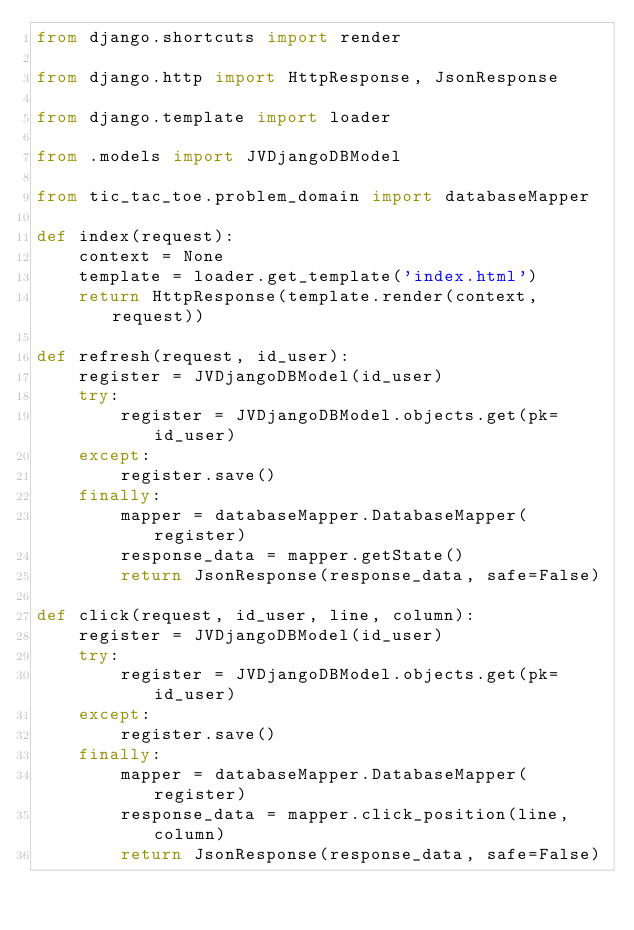Convert code to text. <code><loc_0><loc_0><loc_500><loc_500><_Python_>from django.shortcuts import render

from django.http import HttpResponse, JsonResponse

from django.template import loader

from .models import JVDjangoDBModel

from tic_tac_toe.problem_domain import databaseMapper

def index(request):
    context = None
    template = loader.get_template('index.html')
    return HttpResponse(template.render(context, request))

def refresh(request, id_user):
    register = JVDjangoDBModel(id_user)
    try:
        register = JVDjangoDBModel.objects.get(pk=id_user)
    except:
        register.save()
    finally:
        mapper = databaseMapper.DatabaseMapper(register)
        response_data = mapper.getState()
        return JsonResponse(response_data, safe=False)

def click(request, id_user, line, column):
    register = JVDjangoDBModel(id_user)
    try:
        register = JVDjangoDBModel.objects.get(pk=id_user)
    except:
        register.save()
    finally:
        mapper = databaseMapper.DatabaseMapper(register)
        response_data = mapper.click_position(line, column)
        return JsonResponse(response_data, safe=False)</code> 